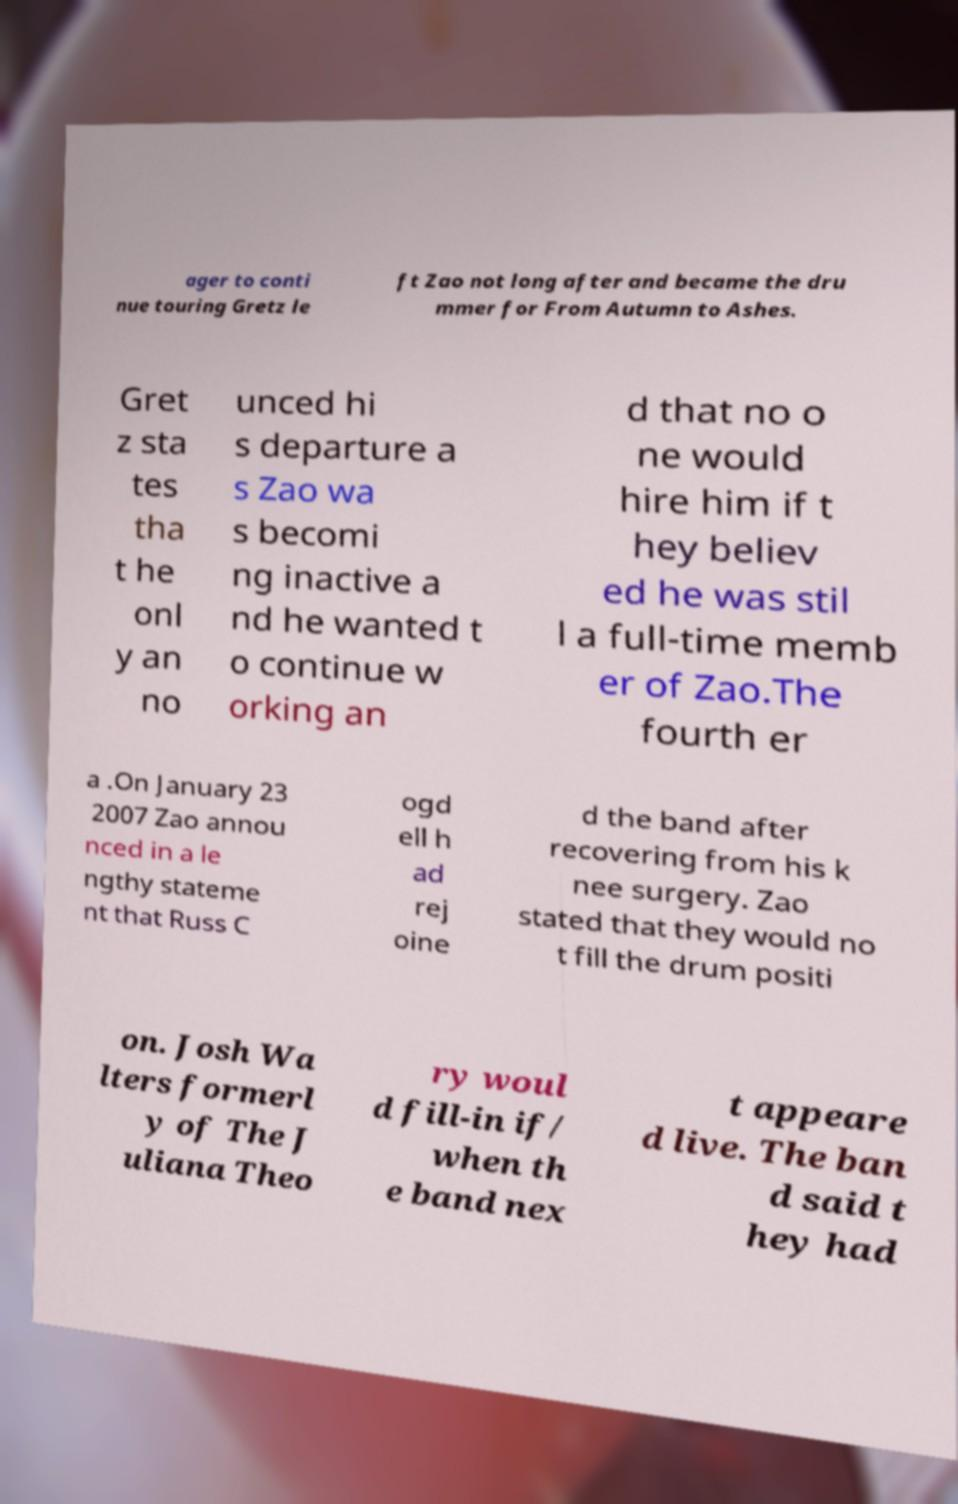Please read and relay the text visible in this image. What does it say? ager to conti nue touring Gretz le ft Zao not long after and became the dru mmer for From Autumn to Ashes. Gret z sta tes tha t he onl y an no unced hi s departure a s Zao wa s becomi ng inactive a nd he wanted t o continue w orking an d that no o ne would hire him if t hey believ ed he was stil l a full-time memb er of Zao.The fourth er a .On January 23 2007 Zao annou nced in a le ngthy stateme nt that Russ C ogd ell h ad rej oine d the band after recovering from his k nee surgery. Zao stated that they would no t fill the drum positi on. Josh Wa lters formerl y of The J uliana Theo ry woul d fill-in if/ when th e band nex t appeare d live. The ban d said t hey had 